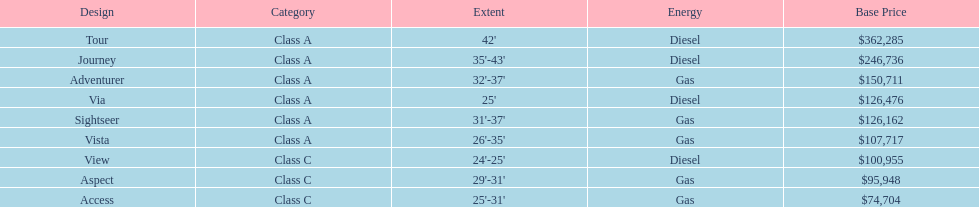Does the tour take diesel or gas? Diesel. 